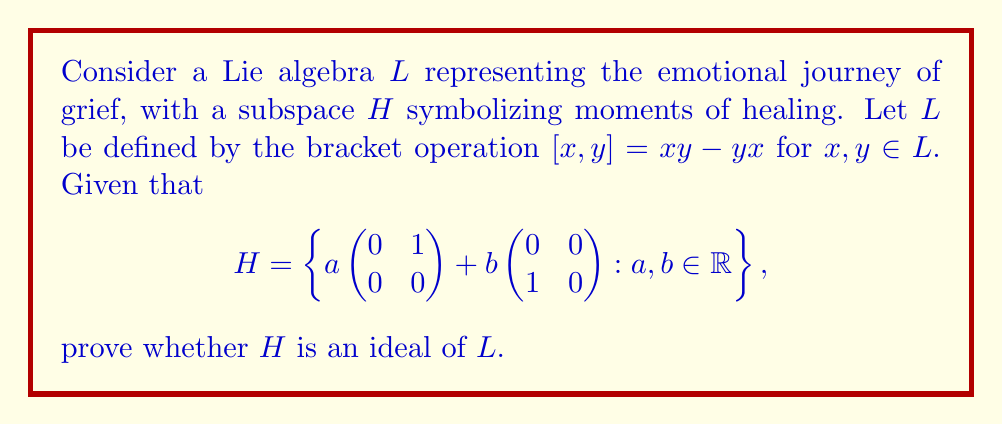Solve this math problem. To prove whether $H$ is an ideal of $L$, we need to show that $[x,h] \in H$ for all $x \in L$ and $h \in H$. Let's approach this step-by-step:

1) First, let's consider a general element $h \in H$:
   $h = a\begin{pmatrix} 0 & 1 \\ 0 & 0 \end{pmatrix} + b\begin{pmatrix} 0 & 0 \\ 1 & 0 \end{pmatrix}$, where $a,b \in \mathbb{R}$

2) Now, consider a general element $x \in L$:
   $x = \begin{pmatrix} p & q \\ r & s \end{pmatrix}$, where $p,q,r,s \in \mathbb{R}$

3) Let's compute $[x,h]$:
   $[x,h] = xh - hx$

4) Calculate $xh$:
   $xh = \begin{pmatrix} p & q \\ r & s \end{pmatrix} (a\begin{pmatrix} 0 & 1 \\ 0 & 0 \end{pmatrix} + b\begin{pmatrix} 0 & 0 \\ 1 & 0 \end{pmatrix})$
   $= a\begin{pmatrix} q & p \\ s & r \end{pmatrix} + b\begin{pmatrix} r & s \\ 0 & 0 \end{pmatrix}$

5) Calculate $hx$:
   $hx = (a\begin{pmatrix} 0 & 1 \\ 0 & 0 \end{pmatrix} + b\begin{pmatrix} 0 & 0 \\ 1 & 0 \end{pmatrix}) \begin{pmatrix} p & q \\ r & s \end{pmatrix}$
   $= a\begin{pmatrix} r & s \\ 0 & 0 \end{pmatrix} + b\begin{pmatrix} 0 & 0 \\ p & q \end{pmatrix}$

6) Now, compute $[x,h] = xh - hx$:
   $[x,h] = (a\begin{pmatrix} q & p \\ s & r \end{pmatrix} + b\begin{pmatrix} r & s \\ 0 & 0 \end{pmatrix}) - (a\begin{pmatrix} r & s \\ 0 & 0 \end{pmatrix} + b\begin{pmatrix} 0 & 0 \\ p & q \end{pmatrix})$
   $= a\begin{pmatrix} q-r & p-s \\ s & r \end{pmatrix} + b\begin{pmatrix} r & s \\ -p & -q \end{pmatrix}$

7) Simplify:
   $[x,h] = \begin{pmatrix} aq-ar+br & ap-as+bs \\ as-bp & ar-bq \end{pmatrix}$

8) For $[x,h]$ to be in $H$, it must have the form $c\begin{pmatrix} 0 & 1 \\ 0 & 0 \end{pmatrix} + d\begin{pmatrix} 0 & 0 \\ 1 & 0 \end{pmatrix}$ for some $c,d \in \mathbb{R}$.

9) Comparing the result in step 7 with the required form, we see that $[x,h]$ is not necessarily in $H$ for all choices of $x$ and $h$, as the diagonal elements and the top-left element are not always zero.

Therefore, $H$ is not an ideal of $L$.
Answer: $H$ is not an ideal of $L$. 